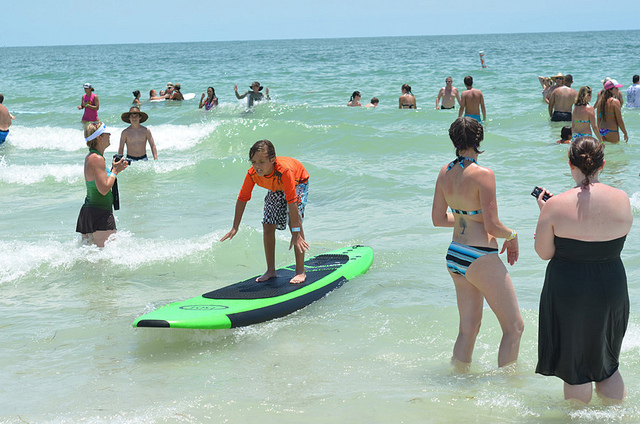What might be the weather condition based on the image? The weather appears to be sunny and warm, as people are swimming and are dressed in swimsuits. What are some safety precautions people might take while engaging in these activities? Some safety precautions include wearing life vests, staying close to the shore, making sure there is a lifeguard on duty, using sunscreen to prevent sunburn, and ensuring that children are supervised at all times. 